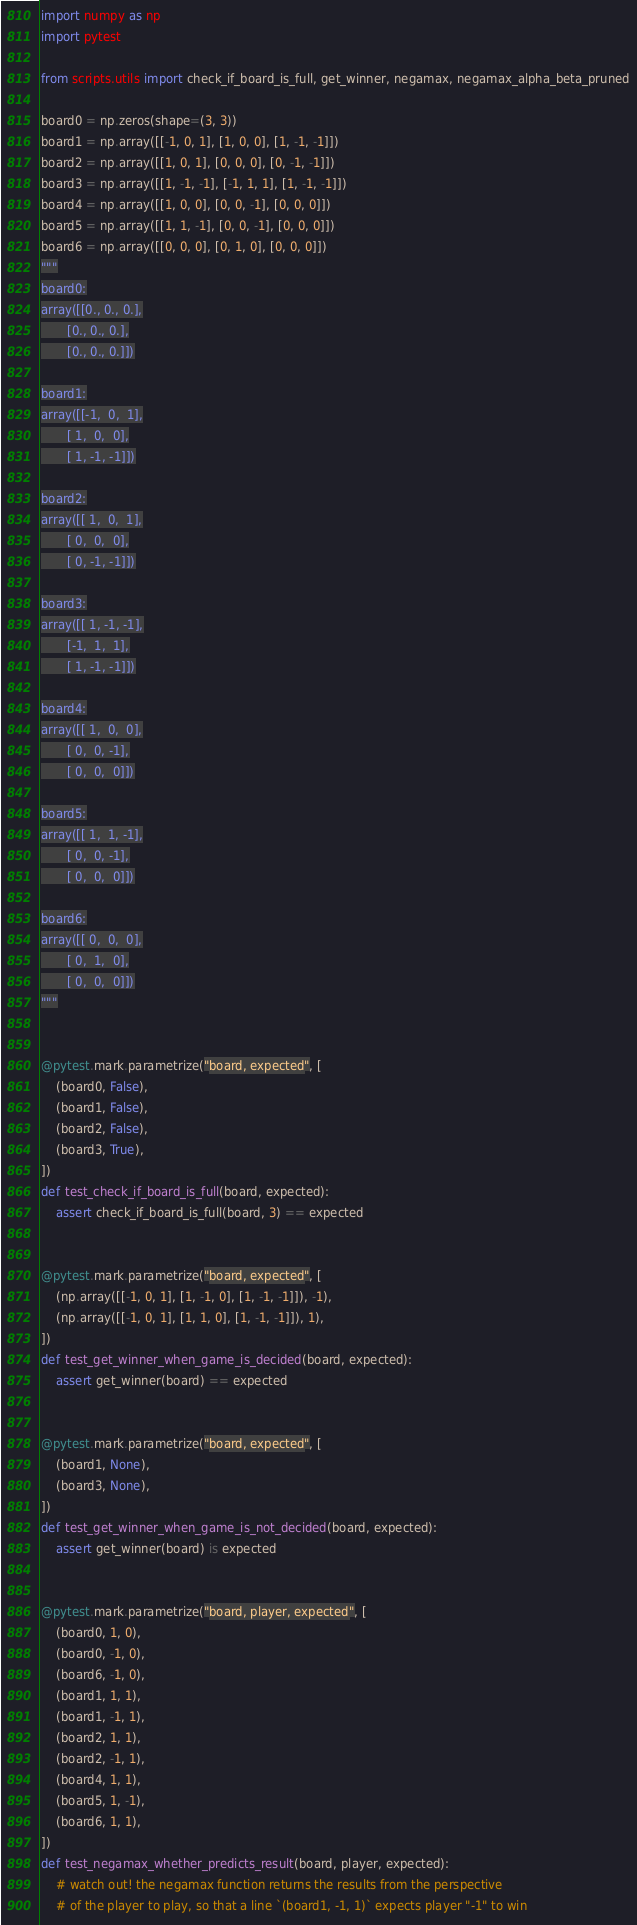Convert code to text. <code><loc_0><loc_0><loc_500><loc_500><_Python_>import numpy as np
import pytest

from scripts.utils import check_if_board_is_full, get_winner, negamax, negamax_alpha_beta_pruned

board0 = np.zeros(shape=(3, 3))
board1 = np.array([[-1, 0, 1], [1, 0, 0], [1, -1, -1]])
board2 = np.array([[1, 0, 1], [0, 0, 0], [0, -1, -1]])
board3 = np.array([[1, -1, -1], [-1, 1, 1], [1, -1, -1]])
board4 = np.array([[1, 0, 0], [0, 0, -1], [0, 0, 0]])
board5 = np.array([[1, 1, -1], [0, 0, -1], [0, 0, 0]])
board6 = np.array([[0, 0, 0], [0, 1, 0], [0, 0, 0]])
"""
board0:
array([[0., 0., 0.],
       [0., 0., 0.],
       [0., 0., 0.]])

board1:
array([[-1,  0,  1],
       [ 1,  0,  0],
       [ 1, -1, -1]])

board2:
array([[ 1,  0,  1],
       [ 0,  0,  0],
       [ 0, -1, -1]])

board3:
array([[ 1, -1, -1],
       [-1,  1,  1],
       [ 1, -1, -1]])

board4:
array([[ 1,  0,  0],
       [ 0,  0, -1],
       [ 0,  0,  0]])

board5:
array([[ 1,  1, -1],
       [ 0,  0, -1],
       [ 0,  0,  0]])

board6:
array([[ 0,  0,  0],
       [ 0,  1,  0],
       [ 0,  0,  0]])
"""


@pytest.mark.parametrize("board, expected", [
    (board0, False),
    (board1, False),
    (board2, False),
    (board3, True),
])
def test_check_if_board_is_full(board, expected):
    assert check_if_board_is_full(board, 3) == expected


@pytest.mark.parametrize("board, expected", [
    (np.array([[-1, 0, 1], [1, -1, 0], [1, -1, -1]]), -1),
    (np.array([[-1, 0, 1], [1, 1, 0], [1, -1, -1]]), 1),
])
def test_get_winner_when_game_is_decided(board, expected):
    assert get_winner(board) == expected


@pytest.mark.parametrize("board, expected", [
    (board1, None),
    (board3, None),
])
def test_get_winner_when_game_is_not_decided(board, expected):
    assert get_winner(board) is expected


@pytest.mark.parametrize("board, player, expected", [
    (board0, 1, 0),
    (board0, -1, 0),
    (board6, -1, 0),
    (board1, 1, 1),
    (board1, -1, 1),
    (board2, 1, 1),
    (board2, -1, 1),
    (board4, 1, 1),
    (board5, 1, -1),
    (board6, 1, 1),
])
def test_negamax_whether_predicts_result(board, player, expected):
    # watch out! the negamax function returns the results from the perspective
    # of the player to play, so that a line `(board1, -1, 1)` expects player "-1" to win</code> 